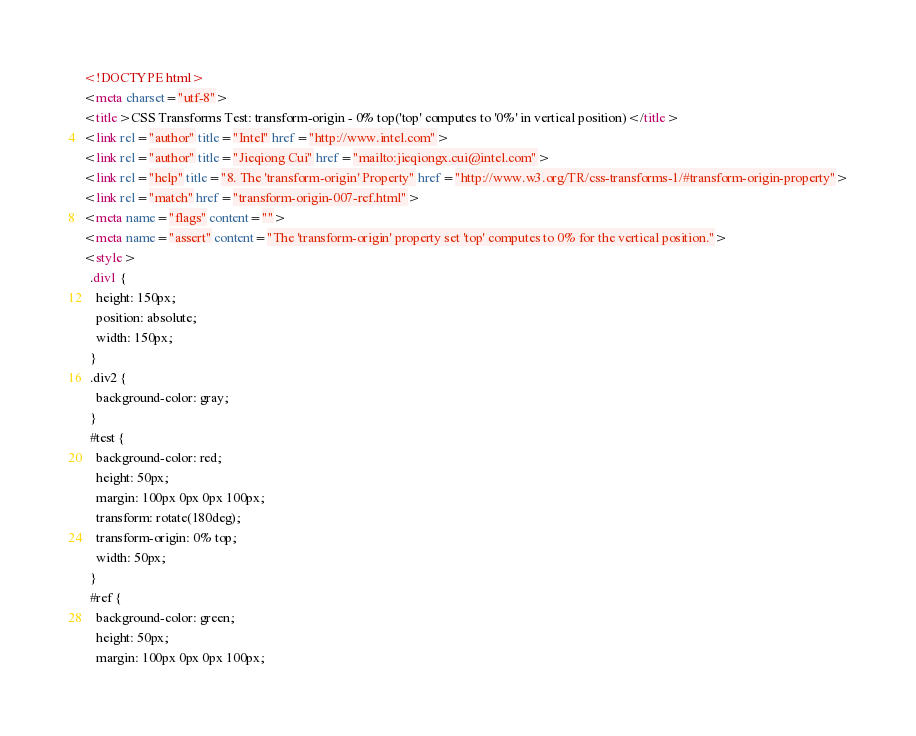<code> <loc_0><loc_0><loc_500><loc_500><_HTML_><!DOCTYPE html>
<meta charset="utf-8">
<title>CSS Transforms Test: transform-origin - 0% top('top' computes to '0%' in vertical position)</title>
<link rel="author" title="Intel" href="http://www.intel.com">
<link rel="author" title="Jieqiong Cui" href="mailto:jieqiongx.cui@intel.com">
<link rel="help" title="8. The 'transform-origin' Property" href="http://www.w3.org/TR/css-transforms-1/#transform-origin-property">
<link rel="match" href="transform-origin-007-ref.html">
<meta name="flags" content="">
<meta name="assert" content="The 'transform-origin' property set 'top' computes to 0% for the vertical position.">
<style>
  .div1 {
    height: 150px;
    position: absolute;
    width: 150px;
  }
  .div2 {
    background-color: gray;
  }
  #test {
    background-color: red;
    height: 50px;
    margin: 100px 0px 0px 100px;
    transform: rotate(180deg);
    transform-origin: 0% top;
    width: 50px;
  }
  #ref {
    background-color: green;
    height: 50px;
    margin: 100px 0px 0px 100px;</code> 